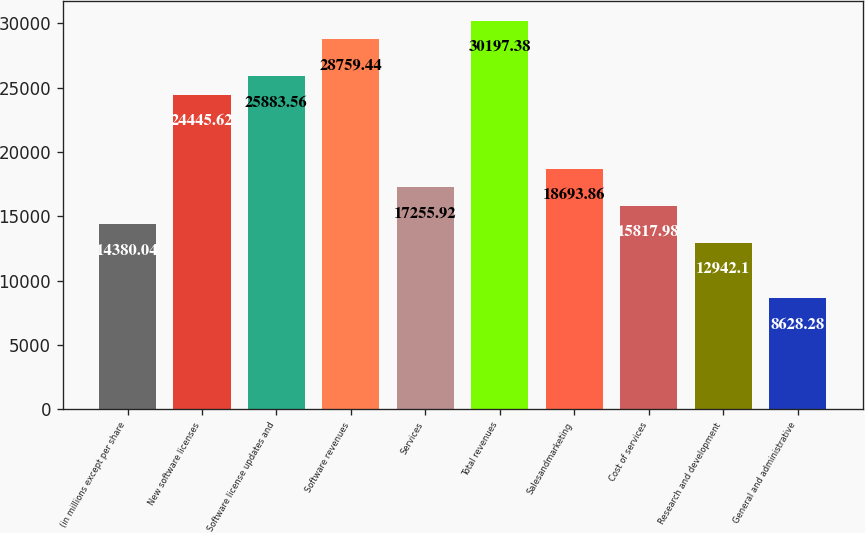Convert chart. <chart><loc_0><loc_0><loc_500><loc_500><bar_chart><fcel>(in millions except per share<fcel>New software licenses<fcel>Software license updates and<fcel>Software revenues<fcel>Services<fcel>Total revenues<fcel>Salesandmarketing<fcel>Cost of services<fcel>Research and development<fcel>General and administrative<nl><fcel>14380<fcel>24445.6<fcel>25883.6<fcel>28759.4<fcel>17255.9<fcel>30197.4<fcel>18693.9<fcel>15818<fcel>12942.1<fcel>8628.28<nl></chart> 